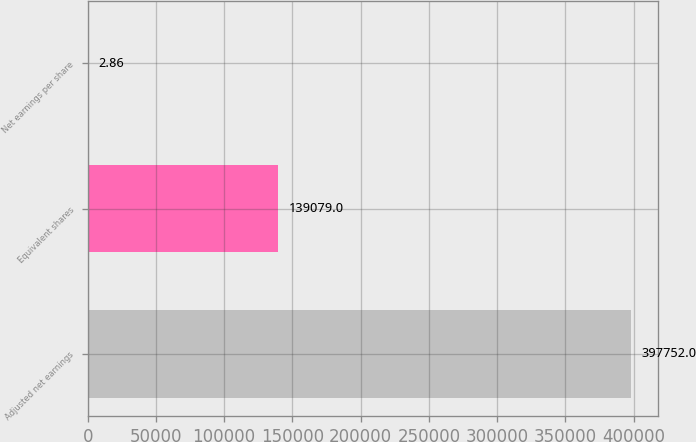Convert chart. <chart><loc_0><loc_0><loc_500><loc_500><bar_chart><fcel>Adjusted net earnings<fcel>Equivalent shares<fcel>Net earnings per share<nl><fcel>397752<fcel>139079<fcel>2.86<nl></chart> 